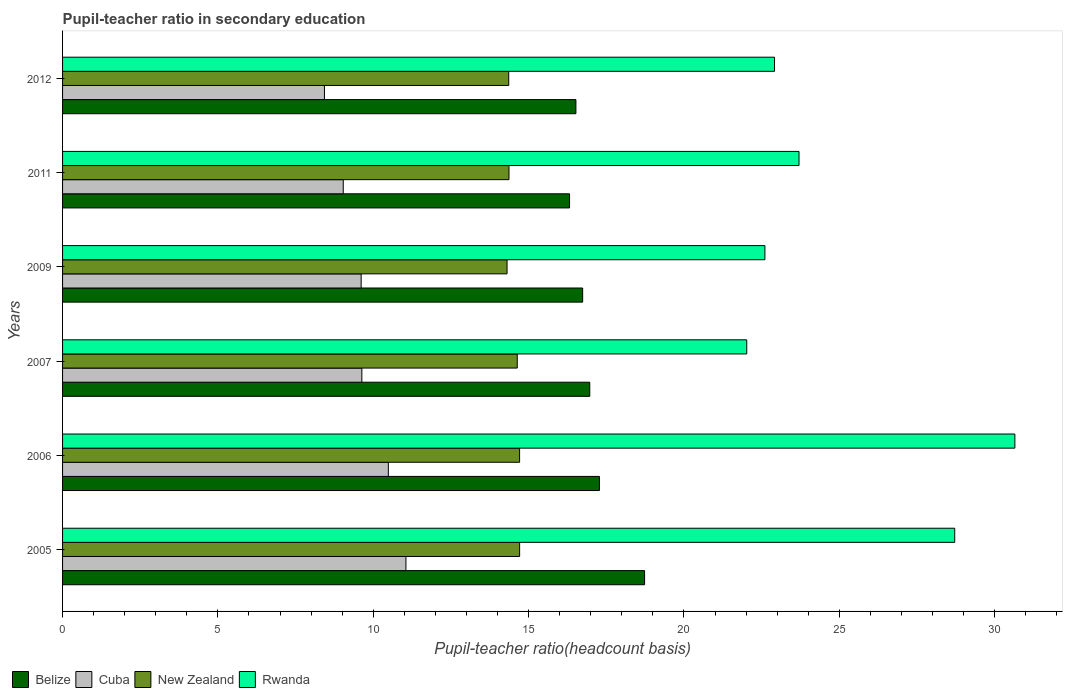How many different coloured bars are there?
Your response must be concise. 4. What is the label of the 5th group of bars from the top?
Ensure brevity in your answer.  2006. In how many cases, is the number of bars for a given year not equal to the number of legend labels?
Your response must be concise. 0. What is the pupil-teacher ratio in secondary education in Belize in 2006?
Provide a short and direct response. 17.28. Across all years, what is the maximum pupil-teacher ratio in secondary education in Cuba?
Offer a very short reply. 11.05. Across all years, what is the minimum pupil-teacher ratio in secondary education in Rwanda?
Your response must be concise. 22.02. What is the total pupil-teacher ratio in secondary education in Belize in the graph?
Your answer should be very brief. 102.56. What is the difference between the pupil-teacher ratio in secondary education in New Zealand in 2007 and that in 2012?
Your response must be concise. 0.27. What is the difference between the pupil-teacher ratio in secondary education in Cuba in 2011 and the pupil-teacher ratio in secondary education in Rwanda in 2012?
Offer a very short reply. -13.88. What is the average pupil-teacher ratio in secondary education in Rwanda per year?
Your response must be concise. 25.1. In the year 2007, what is the difference between the pupil-teacher ratio in secondary education in Rwanda and pupil-teacher ratio in secondary education in Cuba?
Provide a short and direct response. 12.39. In how many years, is the pupil-teacher ratio in secondary education in Cuba greater than 16 ?
Make the answer very short. 0. What is the ratio of the pupil-teacher ratio in secondary education in New Zealand in 2005 to that in 2012?
Provide a succinct answer. 1.02. Is the pupil-teacher ratio in secondary education in Cuba in 2007 less than that in 2009?
Your answer should be very brief. No. What is the difference between the highest and the second highest pupil-teacher ratio in secondary education in Cuba?
Keep it short and to the point. 0.57. What is the difference between the highest and the lowest pupil-teacher ratio in secondary education in Rwanda?
Your response must be concise. 8.63. Is it the case that in every year, the sum of the pupil-teacher ratio in secondary education in Rwanda and pupil-teacher ratio in secondary education in Belize is greater than the sum of pupil-teacher ratio in secondary education in New Zealand and pupil-teacher ratio in secondary education in Cuba?
Keep it short and to the point. Yes. What does the 4th bar from the top in 2006 represents?
Your answer should be compact. Belize. What does the 1st bar from the bottom in 2009 represents?
Make the answer very short. Belize. Is it the case that in every year, the sum of the pupil-teacher ratio in secondary education in Cuba and pupil-teacher ratio in secondary education in Belize is greater than the pupil-teacher ratio in secondary education in Rwanda?
Ensure brevity in your answer.  No. How many bars are there?
Ensure brevity in your answer.  24. Does the graph contain any zero values?
Provide a succinct answer. No. How many legend labels are there?
Offer a very short reply. 4. How are the legend labels stacked?
Ensure brevity in your answer.  Horizontal. What is the title of the graph?
Give a very brief answer. Pupil-teacher ratio in secondary education. Does "Guyana" appear as one of the legend labels in the graph?
Offer a terse response. No. What is the label or title of the X-axis?
Offer a very short reply. Pupil-teacher ratio(headcount basis). What is the label or title of the Y-axis?
Offer a terse response. Years. What is the Pupil-teacher ratio(headcount basis) in Belize in 2005?
Ensure brevity in your answer.  18.73. What is the Pupil-teacher ratio(headcount basis) in Cuba in 2005?
Provide a succinct answer. 11.05. What is the Pupil-teacher ratio(headcount basis) of New Zealand in 2005?
Your answer should be compact. 14.71. What is the Pupil-teacher ratio(headcount basis) in Rwanda in 2005?
Provide a short and direct response. 28.71. What is the Pupil-teacher ratio(headcount basis) in Belize in 2006?
Provide a short and direct response. 17.28. What is the Pupil-teacher ratio(headcount basis) in Cuba in 2006?
Make the answer very short. 10.49. What is the Pupil-teacher ratio(headcount basis) of New Zealand in 2006?
Your response must be concise. 14.71. What is the Pupil-teacher ratio(headcount basis) of Rwanda in 2006?
Offer a very short reply. 30.65. What is the Pupil-teacher ratio(headcount basis) in Belize in 2007?
Offer a very short reply. 16.97. What is the Pupil-teacher ratio(headcount basis) of Cuba in 2007?
Keep it short and to the point. 9.63. What is the Pupil-teacher ratio(headcount basis) in New Zealand in 2007?
Your response must be concise. 14.63. What is the Pupil-teacher ratio(headcount basis) of Rwanda in 2007?
Make the answer very short. 22.02. What is the Pupil-teacher ratio(headcount basis) in Belize in 2009?
Offer a very short reply. 16.74. What is the Pupil-teacher ratio(headcount basis) in Cuba in 2009?
Your answer should be very brief. 9.61. What is the Pupil-teacher ratio(headcount basis) of New Zealand in 2009?
Keep it short and to the point. 14.31. What is the Pupil-teacher ratio(headcount basis) of Rwanda in 2009?
Offer a terse response. 22.61. What is the Pupil-teacher ratio(headcount basis) in Belize in 2011?
Provide a short and direct response. 16.32. What is the Pupil-teacher ratio(headcount basis) of Cuba in 2011?
Ensure brevity in your answer.  9.03. What is the Pupil-teacher ratio(headcount basis) in New Zealand in 2011?
Offer a very short reply. 14.37. What is the Pupil-teacher ratio(headcount basis) in Rwanda in 2011?
Your answer should be very brief. 23.7. What is the Pupil-teacher ratio(headcount basis) in Belize in 2012?
Make the answer very short. 16.52. What is the Pupil-teacher ratio(headcount basis) in Cuba in 2012?
Your answer should be compact. 8.43. What is the Pupil-teacher ratio(headcount basis) in New Zealand in 2012?
Provide a short and direct response. 14.36. What is the Pupil-teacher ratio(headcount basis) of Rwanda in 2012?
Offer a very short reply. 22.91. Across all years, what is the maximum Pupil-teacher ratio(headcount basis) of Belize?
Provide a short and direct response. 18.73. Across all years, what is the maximum Pupil-teacher ratio(headcount basis) of Cuba?
Offer a very short reply. 11.05. Across all years, what is the maximum Pupil-teacher ratio(headcount basis) in New Zealand?
Keep it short and to the point. 14.71. Across all years, what is the maximum Pupil-teacher ratio(headcount basis) in Rwanda?
Give a very brief answer. 30.65. Across all years, what is the minimum Pupil-teacher ratio(headcount basis) in Belize?
Offer a very short reply. 16.32. Across all years, what is the minimum Pupil-teacher ratio(headcount basis) of Cuba?
Provide a short and direct response. 8.43. Across all years, what is the minimum Pupil-teacher ratio(headcount basis) of New Zealand?
Give a very brief answer. 14.31. Across all years, what is the minimum Pupil-teacher ratio(headcount basis) in Rwanda?
Give a very brief answer. 22.02. What is the total Pupil-teacher ratio(headcount basis) in Belize in the graph?
Keep it short and to the point. 102.56. What is the total Pupil-teacher ratio(headcount basis) in Cuba in the graph?
Offer a terse response. 58.24. What is the total Pupil-teacher ratio(headcount basis) of New Zealand in the graph?
Offer a very short reply. 87.09. What is the total Pupil-teacher ratio(headcount basis) of Rwanda in the graph?
Keep it short and to the point. 150.61. What is the difference between the Pupil-teacher ratio(headcount basis) in Belize in 2005 and that in 2006?
Offer a terse response. 1.45. What is the difference between the Pupil-teacher ratio(headcount basis) in Cuba in 2005 and that in 2006?
Offer a very short reply. 0.57. What is the difference between the Pupil-teacher ratio(headcount basis) of New Zealand in 2005 and that in 2006?
Make the answer very short. 0. What is the difference between the Pupil-teacher ratio(headcount basis) of Rwanda in 2005 and that in 2006?
Keep it short and to the point. -1.94. What is the difference between the Pupil-teacher ratio(headcount basis) of Belize in 2005 and that in 2007?
Offer a terse response. 1.76. What is the difference between the Pupil-teacher ratio(headcount basis) of Cuba in 2005 and that in 2007?
Give a very brief answer. 1.42. What is the difference between the Pupil-teacher ratio(headcount basis) in New Zealand in 2005 and that in 2007?
Offer a very short reply. 0.08. What is the difference between the Pupil-teacher ratio(headcount basis) of Rwanda in 2005 and that in 2007?
Give a very brief answer. 6.69. What is the difference between the Pupil-teacher ratio(headcount basis) of Belize in 2005 and that in 2009?
Keep it short and to the point. 1.99. What is the difference between the Pupil-teacher ratio(headcount basis) of Cuba in 2005 and that in 2009?
Give a very brief answer. 1.44. What is the difference between the Pupil-teacher ratio(headcount basis) of New Zealand in 2005 and that in 2009?
Provide a short and direct response. 0.41. What is the difference between the Pupil-teacher ratio(headcount basis) of Rwanda in 2005 and that in 2009?
Your answer should be compact. 6.11. What is the difference between the Pupil-teacher ratio(headcount basis) in Belize in 2005 and that in 2011?
Your answer should be very brief. 2.41. What is the difference between the Pupil-teacher ratio(headcount basis) of Cuba in 2005 and that in 2011?
Make the answer very short. 2.02. What is the difference between the Pupil-teacher ratio(headcount basis) in New Zealand in 2005 and that in 2011?
Offer a very short reply. 0.34. What is the difference between the Pupil-teacher ratio(headcount basis) of Rwanda in 2005 and that in 2011?
Provide a succinct answer. 5.01. What is the difference between the Pupil-teacher ratio(headcount basis) in Belize in 2005 and that in 2012?
Provide a short and direct response. 2.21. What is the difference between the Pupil-teacher ratio(headcount basis) in Cuba in 2005 and that in 2012?
Keep it short and to the point. 2.62. What is the difference between the Pupil-teacher ratio(headcount basis) of New Zealand in 2005 and that in 2012?
Your answer should be very brief. 0.35. What is the difference between the Pupil-teacher ratio(headcount basis) in Rwanda in 2005 and that in 2012?
Provide a succinct answer. 5.8. What is the difference between the Pupil-teacher ratio(headcount basis) in Belize in 2006 and that in 2007?
Offer a terse response. 0.31. What is the difference between the Pupil-teacher ratio(headcount basis) in Cuba in 2006 and that in 2007?
Your answer should be compact. 0.85. What is the difference between the Pupil-teacher ratio(headcount basis) of New Zealand in 2006 and that in 2007?
Offer a very short reply. 0.08. What is the difference between the Pupil-teacher ratio(headcount basis) of Rwanda in 2006 and that in 2007?
Your answer should be compact. 8.63. What is the difference between the Pupil-teacher ratio(headcount basis) in Belize in 2006 and that in 2009?
Make the answer very short. 0.54. What is the difference between the Pupil-teacher ratio(headcount basis) of Cuba in 2006 and that in 2009?
Your answer should be very brief. 0.88. What is the difference between the Pupil-teacher ratio(headcount basis) in New Zealand in 2006 and that in 2009?
Your response must be concise. 0.4. What is the difference between the Pupil-teacher ratio(headcount basis) in Rwanda in 2006 and that in 2009?
Offer a terse response. 8.05. What is the difference between the Pupil-teacher ratio(headcount basis) of Belize in 2006 and that in 2011?
Make the answer very short. 0.96. What is the difference between the Pupil-teacher ratio(headcount basis) of Cuba in 2006 and that in 2011?
Keep it short and to the point. 1.45. What is the difference between the Pupil-teacher ratio(headcount basis) in New Zealand in 2006 and that in 2011?
Provide a succinct answer. 0.34. What is the difference between the Pupil-teacher ratio(headcount basis) in Rwanda in 2006 and that in 2011?
Give a very brief answer. 6.95. What is the difference between the Pupil-teacher ratio(headcount basis) of Belize in 2006 and that in 2012?
Offer a very short reply. 0.76. What is the difference between the Pupil-teacher ratio(headcount basis) in Cuba in 2006 and that in 2012?
Ensure brevity in your answer.  2.06. What is the difference between the Pupil-teacher ratio(headcount basis) in New Zealand in 2006 and that in 2012?
Your answer should be compact. 0.35. What is the difference between the Pupil-teacher ratio(headcount basis) of Rwanda in 2006 and that in 2012?
Give a very brief answer. 7.74. What is the difference between the Pupil-teacher ratio(headcount basis) of Belize in 2007 and that in 2009?
Keep it short and to the point. 0.23. What is the difference between the Pupil-teacher ratio(headcount basis) in Cuba in 2007 and that in 2009?
Provide a succinct answer. 0.02. What is the difference between the Pupil-teacher ratio(headcount basis) of New Zealand in 2007 and that in 2009?
Ensure brevity in your answer.  0.33. What is the difference between the Pupil-teacher ratio(headcount basis) in Rwanda in 2007 and that in 2009?
Offer a very short reply. -0.58. What is the difference between the Pupil-teacher ratio(headcount basis) of Belize in 2007 and that in 2011?
Give a very brief answer. 0.65. What is the difference between the Pupil-teacher ratio(headcount basis) of Cuba in 2007 and that in 2011?
Offer a terse response. 0.6. What is the difference between the Pupil-teacher ratio(headcount basis) of New Zealand in 2007 and that in 2011?
Provide a succinct answer. 0.27. What is the difference between the Pupil-teacher ratio(headcount basis) of Rwanda in 2007 and that in 2011?
Make the answer very short. -1.68. What is the difference between the Pupil-teacher ratio(headcount basis) in Belize in 2007 and that in 2012?
Make the answer very short. 0.45. What is the difference between the Pupil-teacher ratio(headcount basis) of Cuba in 2007 and that in 2012?
Offer a very short reply. 1.2. What is the difference between the Pupil-teacher ratio(headcount basis) in New Zealand in 2007 and that in 2012?
Your answer should be very brief. 0.27. What is the difference between the Pupil-teacher ratio(headcount basis) of Rwanda in 2007 and that in 2012?
Make the answer very short. -0.89. What is the difference between the Pupil-teacher ratio(headcount basis) in Belize in 2009 and that in 2011?
Provide a short and direct response. 0.42. What is the difference between the Pupil-teacher ratio(headcount basis) in Cuba in 2009 and that in 2011?
Provide a succinct answer. 0.58. What is the difference between the Pupil-teacher ratio(headcount basis) of New Zealand in 2009 and that in 2011?
Your answer should be compact. -0.06. What is the difference between the Pupil-teacher ratio(headcount basis) in Rwanda in 2009 and that in 2011?
Your answer should be very brief. -1.1. What is the difference between the Pupil-teacher ratio(headcount basis) of Belize in 2009 and that in 2012?
Ensure brevity in your answer.  0.22. What is the difference between the Pupil-teacher ratio(headcount basis) in Cuba in 2009 and that in 2012?
Offer a very short reply. 1.18. What is the difference between the Pupil-teacher ratio(headcount basis) of New Zealand in 2009 and that in 2012?
Ensure brevity in your answer.  -0.05. What is the difference between the Pupil-teacher ratio(headcount basis) of Rwanda in 2009 and that in 2012?
Your response must be concise. -0.31. What is the difference between the Pupil-teacher ratio(headcount basis) in Belize in 2011 and that in 2012?
Your answer should be very brief. -0.2. What is the difference between the Pupil-teacher ratio(headcount basis) in Cuba in 2011 and that in 2012?
Provide a short and direct response. 0.61. What is the difference between the Pupil-teacher ratio(headcount basis) in New Zealand in 2011 and that in 2012?
Ensure brevity in your answer.  0.01. What is the difference between the Pupil-teacher ratio(headcount basis) of Rwanda in 2011 and that in 2012?
Ensure brevity in your answer.  0.79. What is the difference between the Pupil-teacher ratio(headcount basis) in Belize in 2005 and the Pupil-teacher ratio(headcount basis) in Cuba in 2006?
Make the answer very short. 8.25. What is the difference between the Pupil-teacher ratio(headcount basis) of Belize in 2005 and the Pupil-teacher ratio(headcount basis) of New Zealand in 2006?
Keep it short and to the point. 4.02. What is the difference between the Pupil-teacher ratio(headcount basis) of Belize in 2005 and the Pupil-teacher ratio(headcount basis) of Rwanda in 2006?
Ensure brevity in your answer.  -11.92. What is the difference between the Pupil-teacher ratio(headcount basis) of Cuba in 2005 and the Pupil-teacher ratio(headcount basis) of New Zealand in 2006?
Provide a short and direct response. -3.66. What is the difference between the Pupil-teacher ratio(headcount basis) of Cuba in 2005 and the Pupil-teacher ratio(headcount basis) of Rwanda in 2006?
Your answer should be compact. -19.6. What is the difference between the Pupil-teacher ratio(headcount basis) of New Zealand in 2005 and the Pupil-teacher ratio(headcount basis) of Rwanda in 2006?
Your response must be concise. -15.94. What is the difference between the Pupil-teacher ratio(headcount basis) in Belize in 2005 and the Pupil-teacher ratio(headcount basis) in Cuba in 2007?
Keep it short and to the point. 9.1. What is the difference between the Pupil-teacher ratio(headcount basis) of Belize in 2005 and the Pupil-teacher ratio(headcount basis) of New Zealand in 2007?
Keep it short and to the point. 4.1. What is the difference between the Pupil-teacher ratio(headcount basis) of Belize in 2005 and the Pupil-teacher ratio(headcount basis) of Rwanda in 2007?
Give a very brief answer. -3.29. What is the difference between the Pupil-teacher ratio(headcount basis) of Cuba in 2005 and the Pupil-teacher ratio(headcount basis) of New Zealand in 2007?
Your answer should be very brief. -3.58. What is the difference between the Pupil-teacher ratio(headcount basis) of Cuba in 2005 and the Pupil-teacher ratio(headcount basis) of Rwanda in 2007?
Your answer should be compact. -10.97. What is the difference between the Pupil-teacher ratio(headcount basis) of New Zealand in 2005 and the Pupil-teacher ratio(headcount basis) of Rwanda in 2007?
Offer a terse response. -7.31. What is the difference between the Pupil-teacher ratio(headcount basis) in Belize in 2005 and the Pupil-teacher ratio(headcount basis) in Cuba in 2009?
Your answer should be very brief. 9.12. What is the difference between the Pupil-teacher ratio(headcount basis) of Belize in 2005 and the Pupil-teacher ratio(headcount basis) of New Zealand in 2009?
Make the answer very short. 4.43. What is the difference between the Pupil-teacher ratio(headcount basis) in Belize in 2005 and the Pupil-teacher ratio(headcount basis) in Rwanda in 2009?
Provide a succinct answer. -3.87. What is the difference between the Pupil-teacher ratio(headcount basis) in Cuba in 2005 and the Pupil-teacher ratio(headcount basis) in New Zealand in 2009?
Provide a succinct answer. -3.25. What is the difference between the Pupil-teacher ratio(headcount basis) in Cuba in 2005 and the Pupil-teacher ratio(headcount basis) in Rwanda in 2009?
Keep it short and to the point. -11.55. What is the difference between the Pupil-teacher ratio(headcount basis) of New Zealand in 2005 and the Pupil-teacher ratio(headcount basis) of Rwanda in 2009?
Your response must be concise. -7.89. What is the difference between the Pupil-teacher ratio(headcount basis) in Belize in 2005 and the Pupil-teacher ratio(headcount basis) in Cuba in 2011?
Your response must be concise. 9.7. What is the difference between the Pupil-teacher ratio(headcount basis) of Belize in 2005 and the Pupil-teacher ratio(headcount basis) of New Zealand in 2011?
Provide a short and direct response. 4.36. What is the difference between the Pupil-teacher ratio(headcount basis) of Belize in 2005 and the Pupil-teacher ratio(headcount basis) of Rwanda in 2011?
Your answer should be compact. -4.97. What is the difference between the Pupil-teacher ratio(headcount basis) of Cuba in 2005 and the Pupil-teacher ratio(headcount basis) of New Zealand in 2011?
Make the answer very short. -3.32. What is the difference between the Pupil-teacher ratio(headcount basis) in Cuba in 2005 and the Pupil-teacher ratio(headcount basis) in Rwanda in 2011?
Make the answer very short. -12.65. What is the difference between the Pupil-teacher ratio(headcount basis) in New Zealand in 2005 and the Pupil-teacher ratio(headcount basis) in Rwanda in 2011?
Give a very brief answer. -8.99. What is the difference between the Pupil-teacher ratio(headcount basis) of Belize in 2005 and the Pupil-teacher ratio(headcount basis) of Cuba in 2012?
Give a very brief answer. 10.3. What is the difference between the Pupil-teacher ratio(headcount basis) of Belize in 2005 and the Pupil-teacher ratio(headcount basis) of New Zealand in 2012?
Your response must be concise. 4.37. What is the difference between the Pupil-teacher ratio(headcount basis) of Belize in 2005 and the Pupil-teacher ratio(headcount basis) of Rwanda in 2012?
Keep it short and to the point. -4.18. What is the difference between the Pupil-teacher ratio(headcount basis) in Cuba in 2005 and the Pupil-teacher ratio(headcount basis) in New Zealand in 2012?
Your answer should be compact. -3.31. What is the difference between the Pupil-teacher ratio(headcount basis) in Cuba in 2005 and the Pupil-teacher ratio(headcount basis) in Rwanda in 2012?
Your answer should be very brief. -11.86. What is the difference between the Pupil-teacher ratio(headcount basis) of New Zealand in 2005 and the Pupil-teacher ratio(headcount basis) of Rwanda in 2012?
Your response must be concise. -8.2. What is the difference between the Pupil-teacher ratio(headcount basis) in Belize in 2006 and the Pupil-teacher ratio(headcount basis) in Cuba in 2007?
Offer a very short reply. 7.65. What is the difference between the Pupil-teacher ratio(headcount basis) in Belize in 2006 and the Pupil-teacher ratio(headcount basis) in New Zealand in 2007?
Your response must be concise. 2.65. What is the difference between the Pupil-teacher ratio(headcount basis) of Belize in 2006 and the Pupil-teacher ratio(headcount basis) of Rwanda in 2007?
Your answer should be very brief. -4.74. What is the difference between the Pupil-teacher ratio(headcount basis) of Cuba in 2006 and the Pupil-teacher ratio(headcount basis) of New Zealand in 2007?
Your answer should be very brief. -4.15. What is the difference between the Pupil-teacher ratio(headcount basis) of Cuba in 2006 and the Pupil-teacher ratio(headcount basis) of Rwanda in 2007?
Your answer should be compact. -11.54. What is the difference between the Pupil-teacher ratio(headcount basis) of New Zealand in 2006 and the Pupil-teacher ratio(headcount basis) of Rwanda in 2007?
Provide a succinct answer. -7.31. What is the difference between the Pupil-teacher ratio(headcount basis) of Belize in 2006 and the Pupil-teacher ratio(headcount basis) of Cuba in 2009?
Your answer should be very brief. 7.67. What is the difference between the Pupil-teacher ratio(headcount basis) of Belize in 2006 and the Pupil-teacher ratio(headcount basis) of New Zealand in 2009?
Provide a succinct answer. 2.97. What is the difference between the Pupil-teacher ratio(headcount basis) of Belize in 2006 and the Pupil-teacher ratio(headcount basis) of Rwanda in 2009?
Give a very brief answer. -5.33. What is the difference between the Pupil-teacher ratio(headcount basis) of Cuba in 2006 and the Pupil-teacher ratio(headcount basis) of New Zealand in 2009?
Give a very brief answer. -3.82. What is the difference between the Pupil-teacher ratio(headcount basis) of Cuba in 2006 and the Pupil-teacher ratio(headcount basis) of Rwanda in 2009?
Provide a succinct answer. -12.12. What is the difference between the Pupil-teacher ratio(headcount basis) of New Zealand in 2006 and the Pupil-teacher ratio(headcount basis) of Rwanda in 2009?
Your answer should be compact. -7.9. What is the difference between the Pupil-teacher ratio(headcount basis) in Belize in 2006 and the Pupil-teacher ratio(headcount basis) in Cuba in 2011?
Offer a terse response. 8.25. What is the difference between the Pupil-teacher ratio(headcount basis) in Belize in 2006 and the Pupil-teacher ratio(headcount basis) in New Zealand in 2011?
Your response must be concise. 2.91. What is the difference between the Pupil-teacher ratio(headcount basis) of Belize in 2006 and the Pupil-teacher ratio(headcount basis) of Rwanda in 2011?
Ensure brevity in your answer.  -6.42. What is the difference between the Pupil-teacher ratio(headcount basis) of Cuba in 2006 and the Pupil-teacher ratio(headcount basis) of New Zealand in 2011?
Keep it short and to the point. -3.88. What is the difference between the Pupil-teacher ratio(headcount basis) of Cuba in 2006 and the Pupil-teacher ratio(headcount basis) of Rwanda in 2011?
Make the answer very short. -13.22. What is the difference between the Pupil-teacher ratio(headcount basis) of New Zealand in 2006 and the Pupil-teacher ratio(headcount basis) of Rwanda in 2011?
Offer a terse response. -8.99. What is the difference between the Pupil-teacher ratio(headcount basis) of Belize in 2006 and the Pupil-teacher ratio(headcount basis) of Cuba in 2012?
Provide a succinct answer. 8.85. What is the difference between the Pupil-teacher ratio(headcount basis) in Belize in 2006 and the Pupil-teacher ratio(headcount basis) in New Zealand in 2012?
Your answer should be compact. 2.92. What is the difference between the Pupil-teacher ratio(headcount basis) in Belize in 2006 and the Pupil-teacher ratio(headcount basis) in Rwanda in 2012?
Make the answer very short. -5.63. What is the difference between the Pupil-teacher ratio(headcount basis) in Cuba in 2006 and the Pupil-teacher ratio(headcount basis) in New Zealand in 2012?
Offer a terse response. -3.88. What is the difference between the Pupil-teacher ratio(headcount basis) of Cuba in 2006 and the Pupil-teacher ratio(headcount basis) of Rwanda in 2012?
Your answer should be very brief. -12.43. What is the difference between the Pupil-teacher ratio(headcount basis) in New Zealand in 2006 and the Pupil-teacher ratio(headcount basis) in Rwanda in 2012?
Your answer should be very brief. -8.2. What is the difference between the Pupil-teacher ratio(headcount basis) of Belize in 2007 and the Pupil-teacher ratio(headcount basis) of Cuba in 2009?
Offer a very short reply. 7.36. What is the difference between the Pupil-teacher ratio(headcount basis) of Belize in 2007 and the Pupil-teacher ratio(headcount basis) of New Zealand in 2009?
Your response must be concise. 2.66. What is the difference between the Pupil-teacher ratio(headcount basis) in Belize in 2007 and the Pupil-teacher ratio(headcount basis) in Rwanda in 2009?
Make the answer very short. -5.64. What is the difference between the Pupil-teacher ratio(headcount basis) of Cuba in 2007 and the Pupil-teacher ratio(headcount basis) of New Zealand in 2009?
Your answer should be very brief. -4.67. What is the difference between the Pupil-teacher ratio(headcount basis) in Cuba in 2007 and the Pupil-teacher ratio(headcount basis) in Rwanda in 2009?
Ensure brevity in your answer.  -12.97. What is the difference between the Pupil-teacher ratio(headcount basis) in New Zealand in 2007 and the Pupil-teacher ratio(headcount basis) in Rwanda in 2009?
Offer a very short reply. -7.97. What is the difference between the Pupil-teacher ratio(headcount basis) in Belize in 2007 and the Pupil-teacher ratio(headcount basis) in Cuba in 2011?
Provide a short and direct response. 7.93. What is the difference between the Pupil-teacher ratio(headcount basis) of Belize in 2007 and the Pupil-teacher ratio(headcount basis) of New Zealand in 2011?
Make the answer very short. 2.6. What is the difference between the Pupil-teacher ratio(headcount basis) in Belize in 2007 and the Pupil-teacher ratio(headcount basis) in Rwanda in 2011?
Your answer should be very brief. -6.74. What is the difference between the Pupil-teacher ratio(headcount basis) in Cuba in 2007 and the Pupil-teacher ratio(headcount basis) in New Zealand in 2011?
Your answer should be very brief. -4.74. What is the difference between the Pupil-teacher ratio(headcount basis) of Cuba in 2007 and the Pupil-teacher ratio(headcount basis) of Rwanda in 2011?
Make the answer very short. -14.07. What is the difference between the Pupil-teacher ratio(headcount basis) in New Zealand in 2007 and the Pupil-teacher ratio(headcount basis) in Rwanda in 2011?
Offer a very short reply. -9.07. What is the difference between the Pupil-teacher ratio(headcount basis) in Belize in 2007 and the Pupil-teacher ratio(headcount basis) in Cuba in 2012?
Keep it short and to the point. 8.54. What is the difference between the Pupil-teacher ratio(headcount basis) in Belize in 2007 and the Pupil-teacher ratio(headcount basis) in New Zealand in 2012?
Your answer should be very brief. 2.61. What is the difference between the Pupil-teacher ratio(headcount basis) of Belize in 2007 and the Pupil-teacher ratio(headcount basis) of Rwanda in 2012?
Give a very brief answer. -5.95. What is the difference between the Pupil-teacher ratio(headcount basis) of Cuba in 2007 and the Pupil-teacher ratio(headcount basis) of New Zealand in 2012?
Make the answer very short. -4.73. What is the difference between the Pupil-teacher ratio(headcount basis) of Cuba in 2007 and the Pupil-teacher ratio(headcount basis) of Rwanda in 2012?
Give a very brief answer. -13.28. What is the difference between the Pupil-teacher ratio(headcount basis) in New Zealand in 2007 and the Pupil-teacher ratio(headcount basis) in Rwanda in 2012?
Ensure brevity in your answer.  -8.28. What is the difference between the Pupil-teacher ratio(headcount basis) in Belize in 2009 and the Pupil-teacher ratio(headcount basis) in Cuba in 2011?
Your answer should be compact. 7.71. What is the difference between the Pupil-teacher ratio(headcount basis) of Belize in 2009 and the Pupil-teacher ratio(headcount basis) of New Zealand in 2011?
Your answer should be compact. 2.37. What is the difference between the Pupil-teacher ratio(headcount basis) in Belize in 2009 and the Pupil-teacher ratio(headcount basis) in Rwanda in 2011?
Offer a terse response. -6.96. What is the difference between the Pupil-teacher ratio(headcount basis) of Cuba in 2009 and the Pupil-teacher ratio(headcount basis) of New Zealand in 2011?
Make the answer very short. -4.76. What is the difference between the Pupil-teacher ratio(headcount basis) of Cuba in 2009 and the Pupil-teacher ratio(headcount basis) of Rwanda in 2011?
Your answer should be very brief. -14.09. What is the difference between the Pupil-teacher ratio(headcount basis) of New Zealand in 2009 and the Pupil-teacher ratio(headcount basis) of Rwanda in 2011?
Give a very brief answer. -9.4. What is the difference between the Pupil-teacher ratio(headcount basis) of Belize in 2009 and the Pupil-teacher ratio(headcount basis) of Cuba in 2012?
Provide a short and direct response. 8.31. What is the difference between the Pupil-teacher ratio(headcount basis) in Belize in 2009 and the Pupil-teacher ratio(headcount basis) in New Zealand in 2012?
Give a very brief answer. 2.38. What is the difference between the Pupil-teacher ratio(headcount basis) of Belize in 2009 and the Pupil-teacher ratio(headcount basis) of Rwanda in 2012?
Offer a terse response. -6.18. What is the difference between the Pupil-teacher ratio(headcount basis) of Cuba in 2009 and the Pupil-teacher ratio(headcount basis) of New Zealand in 2012?
Your response must be concise. -4.75. What is the difference between the Pupil-teacher ratio(headcount basis) in Cuba in 2009 and the Pupil-teacher ratio(headcount basis) in Rwanda in 2012?
Give a very brief answer. -13.3. What is the difference between the Pupil-teacher ratio(headcount basis) in New Zealand in 2009 and the Pupil-teacher ratio(headcount basis) in Rwanda in 2012?
Give a very brief answer. -8.61. What is the difference between the Pupil-teacher ratio(headcount basis) of Belize in 2011 and the Pupil-teacher ratio(headcount basis) of Cuba in 2012?
Provide a short and direct response. 7.89. What is the difference between the Pupil-teacher ratio(headcount basis) in Belize in 2011 and the Pupil-teacher ratio(headcount basis) in New Zealand in 2012?
Your response must be concise. 1.96. What is the difference between the Pupil-teacher ratio(headcount basis) in Belize in 2011 and the Pupil-teacher ratio(headcount basis) in Rwanda in 2012?
Your response must be concise. -6.6. What is the difference between the Pupil-teacher ratio(headcount basis) of Cuba in 2011 and the Pupil-teacher ratio(headcount basis) of New Zealand in 2012?
Provide a short and direct response. -5.33. What is the difference between the Pupil-teacher ratio(headcount basis) of Cuba in 2011 and the Pupil-teacher ratio(headcount basis) of Rwanda in 2012?
Your response must be concise. -13.88. What is the difference between the Pupil-teacher ratio(headcount basis) in New Zealand in 2011 and the Pupil-teacher ratio(headcount basis) in Rwanda in 2012?
Your response must be concise. -8.55. What is the average Pupil-teacher ratio(headcount basis) of Belize per year?
Make the answer very short. 17.09. What is the average Pupil-teacher ratio(headcount basis) of Cuba per year?
Your response must be concise. 9.71. What is the average Pupil-teacher ratio(headcount basis) in New Zealand per year?
Give a very brief answer. 14.52. What is the average Pupil-teacher ratio(headcount basis) in Rwanda per year?
Offer a terse response. 25.1. In the year 2005, what is the difference between the Pupil-teacher ratio(headcount basis) in Belize and Pupil-teacher ratio(headcount basis) in Cuba?
Provide a short and direct response. 7.68. In the year 2005, what is the difference between the Pupil-teacher ratio(headcount basis) in Belize and Pupil-teacher ratio(headcount basis) in New Zealand?
Offer a very short reply. 4.02. In the year 2005, what is the difference between the Pupil-teacher ratio(headcount basis) in Belize and Pupil-teacher ratio(headcount basis) in Rwanda?
Offer a very short reply. -9.98. In the year 2005, what is the difference between the Pupil-teacher ratio(headcount basis) of Cuba and Pupil-teacher ratio(headcount basis) of New Zealand?
Give a very brief answer. -3.66. In the year 2005, what is the difference between the Pupil-teacher ratio(headcount basis) of Cuba and Pupil-teacher ratio(headcount basis) of Rwanda?
Keep it short and to the point. -17.66. In the year 2005, what is the difference between the Pupil-teacher ratio(headcount basis) of New Zealand and Pupil-teacher ratio(headcount basis) of Rwanda?
Ensure brevity in your answer.  -14. In the year 2006, what is the difference between the Pupil-teacher ratio(headcount basis) in Belize and Pupil-teacher ratio(headcount basis) in Cuba?
Keep it short and to the point. 6.79. In the year 2006, what is the difference between the Pupil-teacher ratio(headcount basis) in Belize and Pupil-teacher ratio(headcount basis) in New Zealand?
Keep it short and to the point. 2.57. In the year 2006, what is the difference between the Pupil-teacher ratio(headcount basis) in Belize and Pupil-teacher ratio(headcount basis) in Rwanda?
Offer a terse response. -13.37. In the year 2006, what is the difference between the Pupil-teacher ratio(headcount basis) in Cuba and Pupil-teacher ratio(headcount basis) in New Zealand?
Your answer should be very brief. -4.22. In the year 2006, what is the difference between the Pupil-teacher ratio(headcount basis) of Cuba and Pupil-teacher ratio(headcount basis) of Rwanda?
Provide a short and direct response. -20.17. In the year 2006, what is the difference between the Pupil-teacher ratio(headcount basis) of New Zealand and Pupil-teacher ratio(headcount basis) of Rwanda?
Offer a very short reply. -15.94. In the year 2007, what is the difference between the Pupil-teacher ratio(headcount basis) of Belize and Pupil-teacher ratio(headcount basis) of Cuba?
Keep it short and to the point. 7.34. In the year 2007, what is the difference between the Pupil-teacher ratio(headcount basis) of Belize and Pupil-teacher ratio(headcount basis) of New Zealand?
Your response must be concise. 2.33. In the year 2007, what is the difference between the Pupil-teacher ratio(headcount basis) in Belize and Pupil-teacher ratio(headcount basis) in Rwanda?
Give a very brief answer. -5.05. In the year 2007, what is the difference between the Pupil-teacher ratio(headcount basis) of Cuba and Pupil-teacher ratio(headcount basis) of New Zealand?
Ensure brevity in your answer.  -5. In the year 2007, what is the difference between the Pupil-teacher ratio(headcount basis) in Cuba and Pupil-teacher ratio(headcount basis) in Rwanda?
Keep it short and to the point. -12.39. In the year 2007, what is the difference between the Pupil-teacher ratio(headcount basis) of New Zealand and Pupil-teacher ratio(headcount basis) of Rwanda?
Provide a succinct answer. -7.39. In the year 2009, what is the difference between the Pupil-teacher ratio(headcount basis) of Belize and Pupil-teacher ratio(headcount basis) of Cuba?
Provide a short and direct response. 7.13. In the year 2009, what is the difference between the Pupil-teacher ratio(headcount basis) in Belize and Pupil-teacher ratio(headcount basis) in New Zealand?
Offer a terse response. 2.43. In the year 2009, what is the difference between the Pupil-teacher ratio(headcount basis) in Belize and Pupil-teacher ratio(headcount basis) in Rwanda?
Give a very brief answer. -5.87. In the year 2009, what is the difference between the Pupil-teacher ratio(headcount basis) of Cuba and Pupil-teacher ratio(headcount basis) of New Zealand?
Offer a very short reply. -4.7. In the year 2009, what is the difference between the Pupil-teacher ratio(headcount basis) in Cuba and Pupil-teacher ratio(headcount basis) in Rwanda?
Provide a short and direct response. -12.99. In the year 2009, what is the difference between the Pupil-teacher ratio(headcount basis) in New Zealand and Pupil-teacher ratio(headcount basis) in Rwanda?
Ensure brevity in your answer.  -8.3. In the year 2011, what is the difference between the Pupil-teacher ratio(headcount basis) in Belize and Pupil-teacher ratio(headcount basis) in Cuba?
Ensure brevity in your answer.  7.28. In the year 2011, what is the difference between the Pupil-teacher ratio(headcount basis) of Belize and Pupil-teacher ratio(headcount basis) of New Zealand?
Provide a short and direct response. 1.95. In the year 2011, what is the difference between the Pupil-teacher ratio(headcount basis) in Belize and Pupil-teacher ratio(headcount basis) in Rwanda?
Your response must be concise. -7.39. In the year 2011, what is the difference between the Pupil-teacher ratio(headcount basis) of Cuba and Pupil-teacher ratio(headcount basis) of New Zealand?
Give a very brief answer. -5.33. In the year 2011, what is the difference between the Pupil-teacher ratio(headcount basis) in Cuba and Pupil-teacher ratio(headcount basis) in Rwanda?
Provide a succinct answer. -14.67. In the year 2011, what is the difference between the Pupil-teacher ratio(headcount basis) of New Zealand and Pupil-teacher ratio(headcount basis) of Rwanda?
Make the answer very short. -9.34. In the year 2012, what is the difference between the Pupil-teacher ratio(headcount basis) in Belize and Pupil-teacher ratio(headcount basis) in Cuba?
Your response must be concise. 8.09. In the year 2012, what is the difference between the Pupil-teacher ratio(headcount basis) in Belize and Pupil-teacher ratio(headcount basis) in New Zealand?
Give a very brief answer. 2.16. In the year 2012, what is the difference between the Pupil-teacher ratio(headcount basis) in Belize and Pupil-teacher ratio(headcount basis) in Rwanda?
Your answer should be compact. -6.39. In the year 2012, what is the difference between the Pupil-teacher ratio(headcount basis) of Cuba and Pupil-teacher ratio(headcount basis) of New Zealand?
Offer a very short reply. -5.93. In the year 2012, what is the difference between the Pupil-teacher ratio(headcount basis) of Cuba and Pupil-teacher ratio(headcount basis) of Rwanda?
Make the answer very short. -14.49. In the year 2012, what is the difference between the Pupil-teacher ratio(headcount basis) of New Zealand and Pupil-teacher ratio(headcount basis) of Rwanda?
Give a very brief answer. -8.55. What is the ratio of the Pupil-teacher ratio(headcount basis) in Belize in 2005 to that in 2006?
Your response must be concise. 1.08. What is the ratio of the Pupil-teacher ratio(headcount basis) in Cuba in 2005 to that in 2006?
Your answer should be compact. 1.05. What is the ratio of the Pupil-teacher ratio(headcount basis) in Rwanda in 2005 to that in 2006?
Offer a terse response. 0.94. What is the ratio of the Pupil-teacher ratio(headcount basis) in Belize in 2005 to that in 2007?
Offer a very short reply. 1.1. What is the ratio of the Pupil-teacher ratio(headcount basis) of Cuba in 2005 to that in 2007?
Your response must be concise. 1.15. What is the ratio of the Pupil-teacher ratio(headcount basis) of Rwanda in 2005 to that in 2007?
Ensure brevity in your answer.  1.3. What is the ratio of the Pupil-teacher ratio(headcount basis) of Belize in 2005 to that in 2009?
Keep it short and to the point. 1.12. What is the ratio of the Pupil-teacher ratio(headcount basis) in Cuba in 2005 to that in 2009?
Offer a very short reply. 1.15. What is the ratio of the Pupil-teacher ratio(headcount basis) of New Zealand in 2005 to that in 2009?
Offer a very short reply. 1.03. What is the ratio of the Pupil-teacher ratio(headcount basis) in Rwanda in 2005 to that in 2009?
Make the answer very short. 1.27. What is the ratio of the Pupil-teacher ratio(headcount basis) of Belize in 2005 to that in 2011?
Your answer should be very brief. 1.15. What is the ratio of the Pupil-teacher ratio(headcount basis) of Cuba in 2005 to that in 2011?
Keep it short and to the point. 1.22. What is the ratio of the Pupil-teacher ratio(headcount basis) in New Zealand in 2005 to that in 2011?
Your answer should be compact. 1.02. What is the ratio of the Pupil-teacher ratio(headcount basis) of Rwanda in 2005 to that in 2011?
Provide a short and direct response. 1.21. What is the ratio of the Pupil-teacher ratio(headcount basis) of Belize in 2005 to that in 2012?
Keep it short and to the point. 1.13. What is the ratio of the Pupil-teacher ratio(headcount basis) in Cuba in 2005 to that in 2012?
Make the answer very short. 1.31. What is the ratio of the Pupil-teacher ratio(headcount basis) of New Zealand in 2005 to that in 2012?
Offer a terse response. 1.02. What is the ratio of the Pupil-teacher ratio(headcount basis) in Rwanda in 2005 to that in 2012?
Offer a terse response. 1.25. What is the ratio of the Pupil-teacher ratio(headcount basis) in Belize in 2006 to that in 2007?
Offer a very short reply. 1.02. What is the ratio of the Pupil-teacher ratio(headcount basis) of Cuba in 2006 to that in 2007?
Your answer should be compact. 1.09. What is the ratio of the Pupil-teacher ratio(headcount basis) of Rwanda in 2006 to that in 2007?
Give a very brief answer. 1.39. What is the ratio of the Pupil-teacher ratio(headcount basis) in Belize in 2006 to that in 2009?
Give a very brief answer. 1.03. What is the ratio of the Pupil-teacher ratio(headcount basis) in Cuba in 2006 to that in 2009?
Your answer should be very brief. 1.09. What is the ratio of the Pupil-teacher ratio(headcount basis) of New Zealand in 2006 to that in 2009?
Keep it short and to the point. 1.03. What is the ratio of the Pupil-teacher ratio(headcount basis) in Rwanda in 2006 to that in 2009?
Your answer should be very brief. 1.36. What is the ratio of the Pupil-teacher ratio(headcount basis) of Belize in 2006 to that in 2011?
Provide a short and direct response. 1.06. What is the ratio of the Pupil-teacher ratio(headcount basis) in Cuba in 2006 to that in 2011?
Offer a very short reply. 1.16. What is the ratio of the Pupil-teacher ratio(headcount basis) of New Zealand in 2006 to that in 2011?
Ensure brevity in your answer.  1.02. What is the ratio of the Pupil-teacher ratio(headcount basis) in Rwanda in 2006 to that in 2011?
Give a very brief answer. 1.29. What is the ratio of the Pupil-teacher ratio(headcount basis) of Belize in 2006 to that in 2012?
Your answer should be very brief. 1.05. What is the ratio of the Pupil-teacher ratio(headcount basis) of Cuba in 2006 to that in 2012?
Give a very brief answer. 1.24. What is the ratio of the Pupil-teacher ratio(headcount basis) in New Zealand in 2006 to that in 2012?
Offer a terse response. 1.02. What is the ratio of the Pupil-teacher ratio(headcount basis) of Rwanda in 2006 to that in 2012?
Make the answer very short. 1.34. What is the ratio of the Pupil-teacher ratio(headcount basis) of Belize in 2007 to that in 2009?
Make the answer very short. 1.01. What is the ratio of the Pupil-teacher ratio(headcount basis) in Rwanda in 2007 to that in 2009?
Your answer should be compact. 0.97. What is the ratio of the Pupil-teacher ratio(headcount basis) in Belize in 2007 to that in 2011?
Your answer should be compact. 1.04. What is the ratio of the Pupil-teacher ratio(headcount basis) of Cuba in 2007 to that in 2011?
Your answer should be very brief. 1.07. What is the ratio of the Pupil-teacher ratio(headcount basis) of New Zealand in 2007 to that in 2011?
Your response must be concise. 1.02. What is the ratio of the Pupil-teacher ratio(headcount basis) in Rwanda in 2007 to that in 2011?
Your answer should be very brief. 0.93. What is the ratio of the Pupil-teacher ratio(headcount basis) in Cuba in 2007 to that in 2012?
Your answer should be very brief. 1.14. What is the ratio of the Pupil-teacher ratio(headcount basis) of New Zealand in 2007 to that in 2012?
Offer a terse response. 1.02. What is the ratio of the Pupil-teacher ratio(headcount basis) in Rwanda in 2007 to that in 2012?
Your answer should be very brief. 0.96. What is the ratio of the Pupil-teacher ratio(headcount basis) in Belize in 2009 to that in 2011?
Offer a very short reply. 1.03. What is the ratio of the Pupil-teacher ratio(headcount basis) in Cuba in 2009 to that in 2011?
Your answer should be very brief. 1.06. What is the ratio of the Pupil-teacher ratio(headcount basis) in New Zealand in 2009 to that in 2011?
Keep it short and to the point. 1. What is the ratio of the Pupil-teacher ratio(headcount basis) of Rwanda in 2009 to that in 2011?
Offer a terse response. 0.95. What is the ratio of the Pupil-teacher ratio(headcount basis) in Belize in 2009 to that in 2012?
Make the answer very short. 1.01. What is the ratio of the Pupil-teacher ratio(headcount basis) of Cuba in 2009 to that in 2012?
Ensure brevity in your answer.  1.14. What is the ratio of the Pupil-teacher ratio(headcount basis) of New Zealand in 2009 to that in 2012?
Offer a very short reply. 1. What is the ratio of the Pupil-teacher ratio(headcount basis) in Rwanda in 2009 to that in 2012?
Your answer should be compact. 0.99. What is the ratio of the Pupil-teacher ratio(headcount basis) of Belize in 2011 to that in 2012?
Your answer should be compact. 0.99. What is the ratio of the Pupil-teacher ratio(headcount basis) of Cuba in 2011 to that in 2012?
Your answer should be compact. 1.07. What is the ratio of the Pupil-teacher ratio(headcount basis) in New Zealand in 2011 to that in 2012?
Your response must be concise. 1. What is the ratio of the Pupil-teacher ratio(headcount basis) in Rwanda in 2011 to that in 2012?
Offer a very short reply. 1.03. What is the difference between the highest and the second highest Pupil-teacher ratio(headcount basis) of Belize?
Give a very brief answer. 1.45. What is the difference between the highest and the second highest Pupil-teacher ratio(headcount basis) in Cuba?
Give a very brief answer. 0.57. What is the difference between the highest and the second highest Pupil-teacher ratio(headcount basis) in New Zealand?
Provide a succinct answer. 0. What is the difference between the highest and the second highest Pupil-teacher ratio(headcount basis) of Rwanda?
Keep it short and to the point. 1.94. What is the difference between the highest and the lowest Pupil-teacher ratio(headcount basis) in Belize?
Provide a succinct answer. 2.41. What is the difference between the highest and the lowest Pupil-teacher ratio(headcount basis) of Cuba?
Provide a short and direct response. 2.62. What is the difference between the highest and the lowest Pupil-teacher ratio(headcount basis) of New Zealand?
Keep it short and to the point. 0.41. What is the difference between the highest and the lowest Pupil-teacher ratio(headcount basis) in Rwanda?
Offer a terse response. 8.63. 